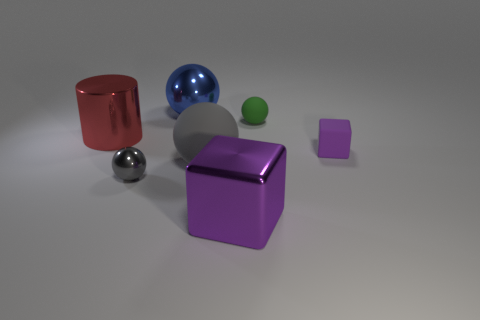Add 3 blue balls. How many objects exist? 10 Subtract all cubes. How many objects are left? 5 Subtract all small balls. Subtract all big red metal cylinders. How many objects are left? 4 Add 2 tiny purple objects. How many tiny purple objects are left? 3 Add 6 large gray rubber cubes. How many large gray rubber cubes exist? 6 Subtract 0 gray blocks. How many objects are left? 7 